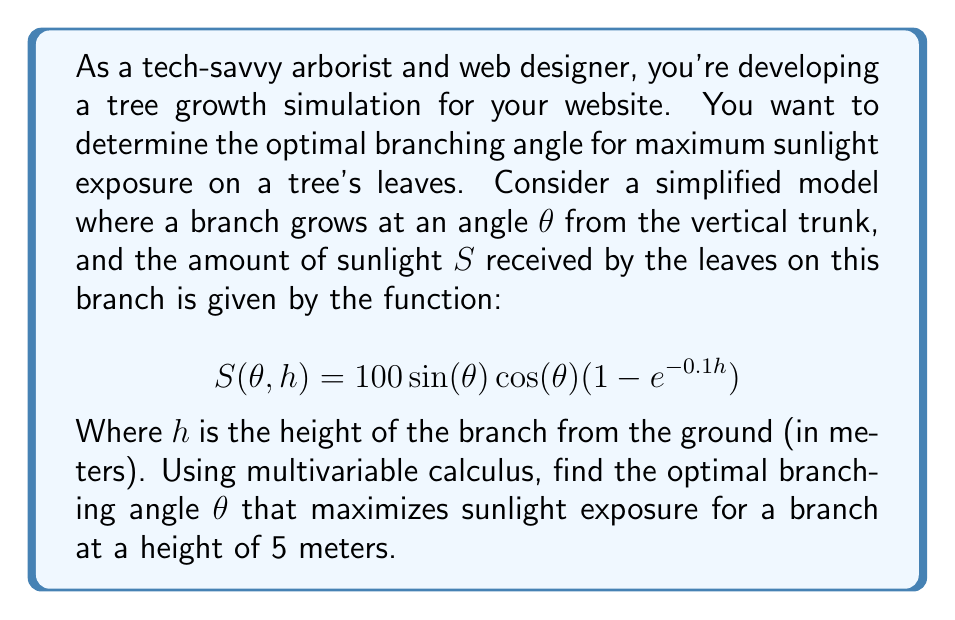Can you solve this math problem? To solve this problem, we'll use partial derivatives and optimization techniques from multivariable calculus.

1. First, we need to find the critical points of the function $S(\theta, h)$ with respect to $\theta$. Since $h$ is given as 5 meters, we can treat it as a constant.

2. Let's substitute $h = 5$ into our function:
   $$S(\theta, 5) = 100 \sin(\theta) \cos(\theta) (1 - e^{-0.5})$$

3. To find the critical points, we need to find the derivative of $S$ with respect to $\theta$ and set it equal to zero:

   $$\frac{\partial S}{\partial \theta} = 100 (\cos^2(\theta) - \sin^2(\theta)) (1 - e^{-0.5}) = 0$$

4. Using the identity $\cos^2(\theta) - \sin^2(\theta) = \cos(2\theta)$, we get:

   $$100 \cos(2\theta) (1 - e^{-0.5}) = 0$$

5. Solving this equation:
   $\cos(2\theta) = 0$
   $2\theta = \frac{\pi}{2}$ or $\frac{3\pi}{2}$
   $\theta = \frac{\pi}{4}$ or $\frac{3\pi}{4}$

6. To determine which of these critical points gives the maximum value, we can use the second derivative test:

   $$\frac{\partial^2 S}{\partial \theta^2} = -200 \sin(2\theta) (1 - e^{-0.5})$$

7. Evaluating at $\theta = \frac{\pi}{4}$:
   $$\frac{\partial^2 S}{\partial \theta^2} \bigg|_{\theta = \frac{\pi}{4}} = -200 \sin(\frac{\pi}{2}) (1 - e^{-0.5}) < 0$$

   This indicates that $\theta = \frac{\pi}{4}$ is a local maximum.

8. Evaluating at $\theta = \frac{3\pi}{4}$:
   $$\frac{\partial^2 S}{\partial \theta^2} \bigg|_{\theta = \frac{3\pi}{4}} = 200 \sin(\frac{3\pi}{2}) (1 - e^{-0.5}) > 0$$

   This indicates that $\theta = \frac{3\pi}{4}$ is a local minimum.

Therefore, the optimal branching angle for maximum sunlight exposure is $\frac{\pi}{4}$ or 45 degrees from the vertical.
Answer: The optimal branching angle for maximum sunlight exposure is $\frac{\pi}{4}$ radians or 45 degrees from the vertical. 